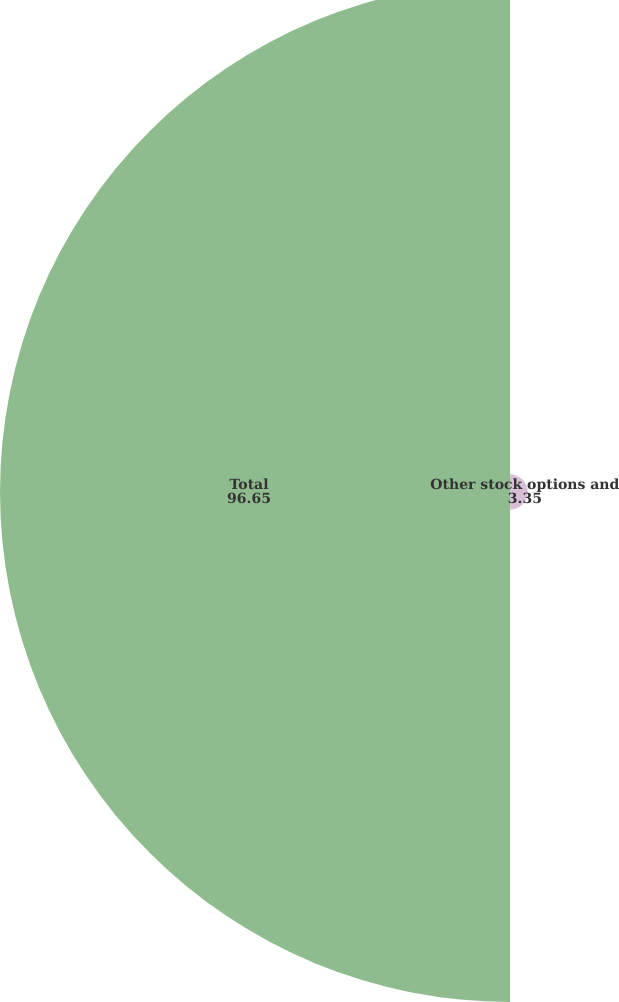Convert chart. <chart><loc_0><loc_0><loc_500><loc_500><pie_chart><fcel>Other stock options and<fcel>Total<nl><fcel>3.35%<fcel>96.65%<nl></chart> 